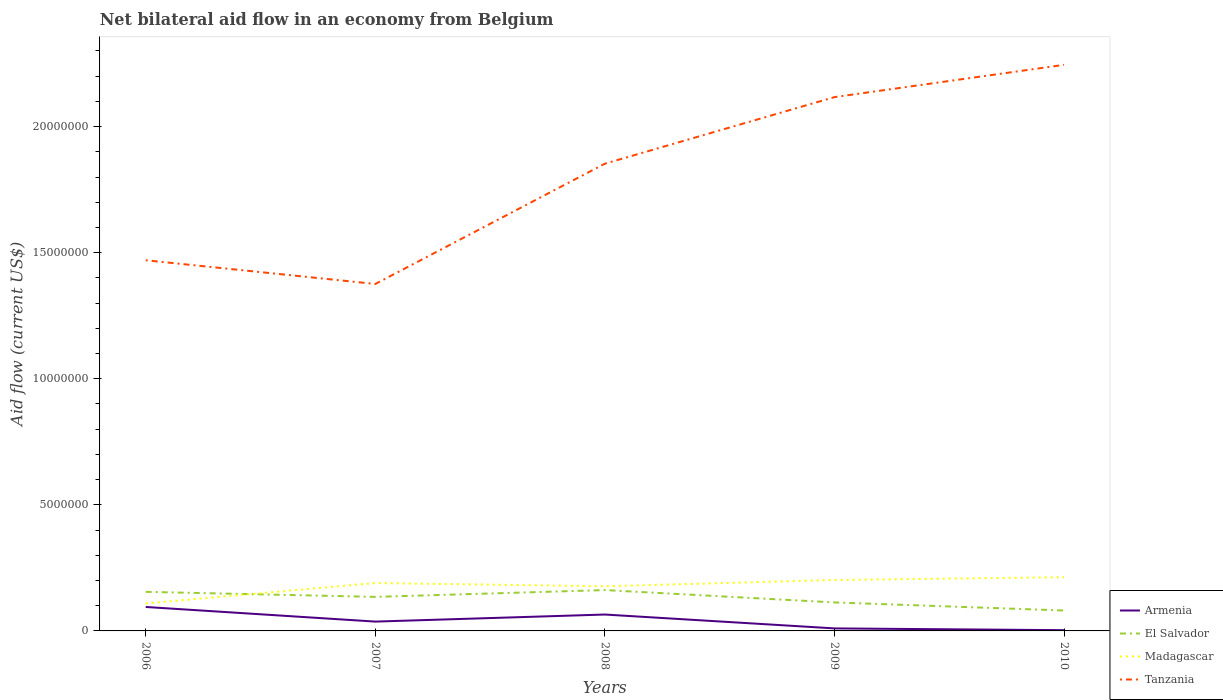Is the number of lines equal to the number of legend labels?
Your response must be concise. Yes. Across all years, what is the maximum net bilateral aid flow in Madagascar?
Provide a succinct answer. 1.09e+06. What is the total net bilateral aid flow in Armenia in the graph?
Your response must be concise. 7.00e+04. What is the difference between the highest and the second highest net bilateral aid flow in Armenia?
Provide a short and direct response. 9.20e+05. How many lines are there?
Provide a succinct answer. 4. How many years are there in the graph?
Your response must be concise. 5. What is the difference between two consecutive major ticks on the Y-axis?
Your answer should be compact. 5.00e+06. Are the values on the major ticks of Y-axis written in scientific E-notation?
Your answer should be very brief. No. Where does the legend appear in the graph?
Keep it short and to the point. Bottom right. How many legend labels are there?
Provide a short and direct response. 4. What is the title of the graph?
Give a very brief answer. Net bilateral aid flow in an economy from Belgium. What is the label or title of the X-axis?
Offer a very short reply. Years. What is the Aid flow (current US$) in Armenia in 2006?
Make the answer very short. 9.50e+05. What is the Aid flow (current US$) in El Salvador in 2006?
Offer a terse response. 1.55e+06. What is the Aid flow (current US$) of Madagascar in 2006?
Your answer should be very brief. 1.09e+06. What is the Aid flow (current US$) of Tanzania in 2006?
Your answer should be very brief. 1.47e+07. What is the Aid flow (current US$) of El Salvador in 2007?
Ensure brevity in your answer.  1.35e+06. What is the Aid flow (current US$) of Madagascar in 2007?
Provide a short and direct response. 1.90e+06. What is the Aid flow (current US$) in Tanzania in 2007?
Your answer should be compact. 1.38e+07. What is the Aid flow (current US$) in Armenia in 2008?
Your answer should be compact. 6.50e+05. What is the Aid flow (current US$) in El Salvador in 2008?
Your answer should be compact. 1.62e+06. What is the Aid flow (current US$) of Madagascar in 2008?
Make the answer very short. 1.77e+06. What is the Aid flow (current US$) of Tanzania in 2008?
Keep it short and to the point. 1.85e+07. What is the Aid flow (current US$) of El Salvador in 2009?
Your response must be concise. 1.13e+06. What is the Aid flow (current US$) in Madagascar in 2009?
Your response must be concise. 2.02e+06. What is the Aid flow (current US$) of Tanzania in 2009?
Give a very brief answer. 2.12e+07. What is the Aid flow (current US$) of El Salvador in 2010?
Your response must be concise. 8.10e+05. What is the Aid flow (current US$) in Madagascar in 2010?
Your answer should be very brief. 2.13e+06. What is the Aid flow (current US$) in Tanzania in 2010?
Provide a succinct answer. 2.24e+07. Across all years, what is the maximum Aid flow (current US$) of Armenia?
Provide a succinct answer. 9.50e+05. Across all years, what is the maximum Aid flow (current US$) of El Salvador?
Provide a short and direct response. 1.62e+06. Across all years, what is the maximum Aid flow (current US$) in Madagascar?
Offer a very short reply. 2.13e+06. Across all years, what is the maximum Aid flow (current US$) in Tanzania?
Ensure brevity in your answer.  2.24e+07. Across all years, what is the minimum Aid flow (current US$) in Armenia?
Make the answer very short. 3.00e+04. Across all years, what is the minimum Aid flow (current US$) of El Salvador?
Offer a very short reply. 8.10e+05. Across all years, what is the minimum Aid flow (current US$) in Madagascar?
Give a very brief answer. 1.09e+06. Across all years, what is the minimum Aid flow (current US$) in Tanzania?
Give a very brief answer. 1.38e+07. What is the total Aid flow (current US$) in Armenia in the graph?
Give a very brief answer. 2.10e+06. What is the total Aid flow (current US$) of El Salvador in the graph?
Your response must be concise. 6.46e+06. What is the total Aid flow (current US$) in Madagascar in the graph?
Your answer should be very brief. 8.91e+06. What is the total Aid flow (current US$) of Tanzania in the graph?
Make the answer very short. 9.06e+07. What is the difference between the Aid flow (current US$) of Armenia in 2006 and that in 2007?
Your answer should be very brief. 5.80e+05. What is the difference between the Aid flow (current US$) of El Salvador in 2006 and that in 2007?
Ensure brevity in your answer.  2.00e+05. What is the difference between the Aid flow (current US$) of Madagascar in 2006 and that in 2007?
Your answer should be very brief. -8.10e+05. What is the difference between the Aid flow (current US$) of Tanzania in 2006 and that in 2007?
Offer a terse response. 9.40e+05. What is the difference between the Aid flow (current US$) in El Salvador in 2006 and that in 2008?
Ensure brevity in your answer.  -7.00e+04. What is the difference between the Aid flow (current US$) of Madagascar in 2006 and that in 2008?
Your answer should be compact. -6.80e+05. What is the difference between the Aid flow (current US$) of Tanzania in 2006 and that in 2008?
Keep it short and to the point. -3.83e+06. What is the difference between the Aid flow (current US$) of Armenia in 2006 and that in 2009?
Your answer should be very brief. 8.50e+05. What is the difference between the Aid flow (current US$) of El Salvador in 2006 and that in 2009?
Offer a very short reply. 4.20e+05. What is the difference between the Aid flow (current US$) in Madagascar in 2006 and that in 2009?
Your response must be concise. -9.30e+05. What is the difference between the Aid flow (current US$) of Tanzania in 2006 and that in 2009?
Provide a succinct answer. -6.47e+06. What is the difference between the Aid flow (current US$) of Armenia in 2006 and that in 2010?
Ensure brevity in your answer.  9.20e+05. What is the difference between the Aid flow (current US$) of El Salvador in 2006 and that in 2010?
Make the answer very short. 7.40e+05. What is the difference between the Aid flow (current US$) in Madagascar in 2006 and that in 2010?
Give a very brief answer. -1.04e+06. What is the difference between the Aid flow (current US$) in Tanzania in 2006 and that in 2010?
Your answer should be compact. -7.75e+06. What is the difference between the Aid flow (current US$) of Armenia in 2007 and that in 2008?
Provide a short and direct response. -2.80e+05. What is the difference between the Aid flow (current US$) in El Salvador in 2007 and that in 2008?
Make the answer very short. -2.70e+05. What is the difference between the Aid flow (current US$) in Madagascar in 2007 and that in 2008?
Give a very brief answer. 1.30e+05. What is the difference between the Aid flow (current US$) of Tanzania in 2007 and that in 2008?
Ensure brevity in your answer.  -4.77e+06. What is the difference between the Aid flow (current US$) of Armenia in 2007 and that in 2009?
Provide a short and direct response. 2.70e+05. What is the difference between the Aid flow (current US$) of El Salvador in 2007 and that in 2009?
Make the answer very short. 2.20e+05. What is the difference between the Aid flow (current US$) of Tanzania in 2007 and that in 2009?
Provide a succinct answer. -7.41e+06. What is the difference between the Aid flow (current US$) of El Salvador in 2007 and that in 2010?
Keep it short and to the point. 5.40e+05. What is the difference between the Aid flow (current US$) of Tanzania in 2007 and that in 2010?
Give a very brief answer. -8.69e+06. What is the difference between the Aid flow (current US$) in El Salvador in 2008 and that in 2009?
Your answer should be very brief. 4.90e+05. What is the difference between the Aid flow (current US$) in Madagascar in 2008 and that in 2009?
Your response must be concise. -2.50e+05. What is the difference between the Aid flow (current US$) in Tanzania in 2008 and that in 2009?
Ensure brevity in your answer.  -2.64e+06. What is the difference between the Aid flow (current US$) in Armenia in 2008 and that in 2010?
Give a very brief answer. 6.20e+05. What is the difference between the Aid flow (current US$) of El Salvador in 2008 and that in 2010?
Offer a terse response. 8.10e+05. What is the difference between the Aid flow (current US$) of Madagascar in 2008 and that in 2010?
Keep it short and to the point. -3.60e+05. What is the difference between the Aid flow (current US$) in Tanzania in 2008 and that in 2010?
Your answer should be compact. -3.92e+06. What is the difference between the Aid flow (current US$) of Armenia in 2009 and that in 2010?
Give a very brief answer. 7.00e+04. What is the difference between the Aid flow (current US$) of Madagascar in 2009 and that in 2010?
Provide a short and direct response. -1.10e+05. What is the difference between the Aid flow (current US$) in Tanzania in 2009 and that in 2010?
Make the answer very short. -1.28e+06. What is the difference between the Aid flow (current US$) in Armenia in 2006 and the Aid flow (current US$) in El Salvador in 2007?
Make the answer very short. -4.00e+05. What is the difference between the Aid flow (current US$) of Armenia in 2006 and the Aid flow (current US$) of Madagascar in 2007?
Provide a short and direct response. -9.50e+05. What is the difference between the Aid flow (current US$) in Armenia in 2006 and the Aid flow (current US$) in Tanzania in 2007?
Keep it short and to the point. -1.28e+07. What is the difference between the Aid flow (current US$) of El Salvador in 2006 and the Aid flow (current US$) of Madagascar in 2007?
Give a very brief answer. -3.50e+05. What is the difference between the Aid flow (current US$) in El Salvador in 2006 and the Aid flow (current US$) in Tanzania in 2007?
Make the answer very short. -1.22e+07. What is the difference between the Aid flow (current US$) in Madagascar in 2006 and the Aid flow (current US$) in Tanzania in 2007?
Provide a short and direct response. -1.27e+07. What is the difference between the Aid flow (current US$) of Armenia in 2006 and the Aid flow (current US$) of El Salvador in 2008?
Your answer should be compact. -6.70e+05. What is the difference between the Aid flow (current US$) in Armenia in 2006 and the Aid flow (current US$) in Madagascar in 2008?
Give a very brief answer. -8.20e+05. What is the difference between the Aid flow (current US$) of Armenia in 2006 and the Aid flow (current US$) of Tanzania in 2008?
Provide a short and direct response. -1.76e+07. What is the difference between the Aid flow (current US$) of El Salvador in 2006 and the Aid flow (current US$) of Tanzania in 2008?
Offer a very short reply. -1.70e+07. What is the difference between the Aid flow (current US$) of Madagascar in 2006 and the Aid flow (current US$) of Tanzania in 2008?
Offer a very short reply. -1.74e+07. What is the difference between the Aid flow (current US$) in Armenia in 2006 and the Aid flow (current US$) in El Salvador in 2009?
Give a very brief answer. -1.80e+05. What is the difference between the Aid flow (current US$) of Armenia in 2006 and the Aid flow (current US$) of Madagascar in 2009?
Ensure brevity in your answer.  -1.07e+06. What is the difference between the Aid flow (current US$) of Armenia in 2006 and the Aid flow (current US$) of Tanzania in 2009?
Keep it short and to the point. -2.02e+07. What is the difference between the Aid flow (current US$) of El Salvador in 2006 and the Aid flow (current US$) of Madagascar in 2009?
Your answer should be compact. -4.70e+05. What is the difference between the Aid flow (current US$) in El Salvador in 2006 and the Aid flow (current US$) in Tanzania in 2009?
Your response must be concise. -1.96e+07. What is the difference between the Aid flow (current US$) of Madagascar in 2006 and the Aid flow (current US$) of Tanzania in 2009?
Make the answer very short. -2.01e+07. What is the difference between the Aid flow (current US$) in Armenia in 2006 and the Aid flow (current US$) in Madagascar in 2010?
Make the answer very short. -1.18e+06. What is the difference between the Aid flow (current US$) of Armenia in 2006 and the Aid flow (current US$) of Tanzania in 2010?
Offer a terse response. -2.15e+07. What is the difference between the Aid flow (current US$) in El Salvador in 2006 and the Aid flow (current US$) in Madagascar in 2010?
Ensure brevity in your answer.  -5.80e+05. What is the difference between the Aid flow (current US$) in El Salvador in 2006 and the Aid flow (current US$) in Tanzania in 2010?
Make the answer very short. -2.09e+07. What is the difference between the Aid flow (current US$) of Madagascar in 2006 and the Aid flow (current US$) of Tanzania in 2010?
Offer a terse response. -2.14e+07. What is the difference between the Aid flow (current US$) of Armenia in 2007 and the Aid flow (current US$) of El Salvador in 2008?
Offer a terse response. -1.25e+06. What is the difference between the Aid flow (current US$) in Armenia in 2007 and the Aid flow (current US$) in Madagascar in 2008?
Provide a succinct answer. -1.40e+06. What is the difference between the Aid flow (current US$) of Armenia in 2007 and the Aid flow (current US$) of Tanzania in 2008?
Provide a short and direct response. -1.82e+07. What is the difference between the Aid flow (current US$) of El Salvador in 2007 and the Aid flow (current US$) of Madagascar in 2008?
Your answer should be very brief. -4.20e+05. What is the difference between the Aid flow (current US$) of El Salvador in 2007 and the Aid flow (current US$) of Tanzania in 2008?
Provide a succinct answer. -1.72e+07. What is the difference between the Aid flow (current US$) of Madagascar in 2007 and the Aid flow (current US$) of Tanzania in 2008?
Your answer should be very brief. -1.66e+07. What is the difference between the Aid flow (current US$) in Armenia in 2007 and the Aid flow (current US$) in El Salvador in 2009?
Provide a succinct answer. -7.60e+05. What is the difference between the Aid flow (current US$) of Armenia in 2007 and the Aid flow (current US$) of Madagascar in 2009?
Keep it short and to the point. -1.65e+06. What is the difference between the Aid flow (current US$) in Armenia in 2007 and the Aid flow (current US$) in Tanzania in 2009?
Offer a very short reply. -2.08e+07. What is the difference between the Aid flow (current US$) of El Salvador in 2007 and the Aid flow (current US$) of Madagascar in 2009?
Your answer should be compact. -6.70e+05. What is the difference between the Aid flow (current US$) in El Salvador in 2007 and the Aid flow (current US$) in Tanzania in 2009?
Your response must be concise. -1.98e+07. What is the difference between the Aid flow (current US$) in Madagascar in 2007 and the Aid flow (current US$) in Tanzania in 2009?
Offer a terse response. -1.93e+07. What is the difference between the Aid flow (current US$) of Armenia in 2007 and the Aid flow (current US$) of El Salvador in 2010?
Provide a succinct answer. -4.40e+05. What is the difference between the Aid flow (current US$) in Armenia in 2007 and the Aid flow (current US$) in Madagascar in 2010?
Your response must be concise. -1.76e+06. What is the difference between the Aid flow (current US$) in Armenia in 2007 and the Aid flow (current US$) in Tanzania in 2010?
Ensure brevity in your answer.  -2.21e+07. What is the difference between the Aid flow (current US$) in El Salvador in 2007 and the Aid flow (current US$) in Madagascar in 2010?
Your answer should be compact. -7.80e+05. What is the difference between the Aid flow (current US$) of El Salvador in 2007 and the Aid flow (current US$) of Tanzania in 2010?
Offer a terse response. -2.11e+07. What is the difference between the Aid flow (current US$) of Madagascar in 2007 and the Aid flow (current US$) of Tanzania in 2010?
Your answer should be very brief. -2.06e+07. What is the difference between the Aid flow (current US$) of Armenia in 2008 and the Aid flow (current US$) of El Salvador in 2009?
Make the answer very short. -4.80e+05. What is the difference between the Aid flow (current US$) in Armenia in 2008 and the Aid flow (current US$) in Madagascar in 2009?
Make the answer very short. -1.37e+06. What is the difference between the Aid flow (current US$) of Armenia in 2008 and the Aid flow (current US$) of Tanzania in 2009?
Your answer should be compact. -2.05e+07. What is the difference between the Aid flow (current US$) of El Salvador in 2008 and the Aid flow (current US$) of Madagascar in 2009?
Your answer should be very brief. -4.00e+05. What is the difference between the Aid flow (current US$) in El Salvador in 2008 and the Aid flow (current US$) in Tanzania in 2009?
Provide a succinct answer. -1.96e+07. What is the difference between the Aid flow (current US$) in Madagascar in 2008 and the Aid flow (current US$) in Tanzania in 2009?
Offer a very short reply. -1.94e+07. What is the difference between the Aid flow (current US$) of Armenia in 2008 and the Aid flow (current US$) of El Salvador in 2010?
Offer a terse response. -1.60e+05. What is the difference between the Aid flow (current US$) in Armenia in 2008 and the Aid flow (current US$) in Madagascar in 2010?
Provide a short and direct response. -1.48e+06. What is the difference between the Aid flow (current US$) of Armenia in 2008 and the Aid flow (current US$) of Tanzania in 2010?
Provide a short and direct response. -2.18e+07. What is the difference between the Aid flow (current US$) of El Salvador in 2008 and the Aid flow (current US$) of Madagascar in 2010?
Your response must be concise. -5.10e+05. What is the difference between the Aid flow (current US$) of El Salvador in 2008 and the Aid flow (current US$) of Tanzania in 2010?
Make the answer very short. -2.08e+07. What is the difference between the Aid flow (current US$) in Madagascar in 2008 and the Aid flow (current US$) in Tanzania in 2010?
Your response must be concise. -2.07e+07. What is the difference between the Aid flow (current US$) in Armenia in 2009 and the Aid flow (current US$) in El Salvador in 2010?
Your response must be concise. -7.10e+05. What is the difference between the Aid flow (current US$) of Armenia in 2009 and the Aid flow (current US$) of Madagascar in 2010?
Keep it short and to the point. -2.03e+06. What is the difference between the Aid flow (current US$) of Armenia in 2009 and the Aid flow (current US$) of Tanzania in 2010?
Your response must be concise. -2.24e+07. What is the difference between the Aid flow (current US$) of El Salvador in 2009 and the Aid flow (current US$) of Tanzania in 2010?
Offer a very short reply. -2.13e+07. What is the difference between the Aid flow (current US$) in Madagascar in 2009 and the Aid flow (current US$) in Tanzania in 2010?
Offer a terse response. -2.04e+07. What is the average Aid flow (current US$) of El Salvador per year?
Offer a terse response. 1.29e+06. What is the average Aid flow (current US$) in Madagascar per year?
Your answer should be compact. 1.78e+06. What is the average Aid flow (current US$) in Tanzania per year?
Provide a succinct answer. 1.81e+07. In the year 2006, what is the difference between the Aid flow (current US$) in Armenia and Aid flow (current US$) in El Salvador?
Provide a succinct answer. -6.00e+05. In the year 2006, what is the difference between the Aid flow (current US$) of Armenia and Aid flow (current US$) of Madagascar?
Ensure brevity in your answer.  -1.40e+05. In the year 2006, what is the difference between the Aid flow (current US$) of Armenia and Aid flow (current US$) of Tanzania?
Provide a succinct answer. -1.38e+07. In the year 2006, what is the difference between the Aid flow (current US$) of El Salvador and Aid flow (current US$) of Madagascar?
Keep it short and to the point. 4.60e+05. In the year 2006, what is the difference between the Aid flow (current US$) of El Salvador and Aid flow (current US$) of Tanzania?
Offer a terse response. -1.32e+07. In the year 2006, what is the difference between the Aid flow (current US$) of Madagascar and Aid flow (current US$) of Tanzania?
Offer a terse response. -1.36e+07. In the year 2007, what is the difference between the Aid flow (current US$) in Armenia and Aid flow (current US$) in El Salvador?
Provide a succinct answer. -9.80e+05. In the year 2007, what is the difference between the Aid flow (current US$) of Armenia and Aid flow (current US$) of Madagascar?
Offer a very short reply. -1.53e+06. In the year 2007, what is the difference between the Aid flow (current US$) in Armenia and Aid flow (current US$) in Tanzania?
Keep it short and to the point. -1.34e+07. In the year 2007, what is the difference between the Aid flow (current US$) of El Salvador and Aid flow (current US$) of Madagascar?
Ensure brevity in your answer.  -5.50e+05. In the year 2007, what is the difference between the Aid flow (current US$) of El Salvador and Aid flow (current US$) of Tanzania?
Offer a terse response. -1.24e+07. In the year 2007, what is the difference between the Aid flow (current US$) in Madagascar and Aid flow (current US$) in Tanzania?
Keep it short and to the point. -1.19e+07. In the year 2008, what is the difference between the Aid flow (current US$) in Armenia and Aid flow (current US$) in El Salvador?
Keep it short and to the point. -9.70e+05. In the year 2008, what is the difference between the Aid flow (current US$) in Armenia and Aid flow (current US$) in Madagascar?
Give a very brief answer. -1.12e+06. In the year 2008, what is the difference between the Aid flow (current US$) of Armenia and Aid flow (current US$) of Tanzania?
Your answer should be compact. -1.79e+07. In the year 2008, what is the difference between the Aid flow (current US$) of El Salvador and Aid flow (current US$) of Tanzania?
Provide a succinct answer. -1.69e+07. In the year 2008, what is the difference between the Aid flow (current US$) of Madagascar and Aid flow (current US$) of Tanzania?
Offer a very short reply. -1.68e+07. In the year 2009, what is the difference between the Aid flow (current US$) in Armenia and Aid flow (current US$) in El Salvador?
Your response must be concise. -1.03e+06. In the year 2009, what is the difference between the Aid flow (current US$) of Armenia and Aid flow (current US$) of Madagascar?
Keep it short and to the point. -1.92e+06. In the year 2009, what is the difference between the Aid flow (current US$) in Armenia and Aid flow (current US$) in Tanzania?
Your answer should be very brief. -2.11e+07. In the year 2009, what is the difference between the Aid flow (current US$) of El Salvador and Aid flow (current US$) of Madagascar?
Keep it short and to the point. -8.90e+05. In the year 2009, what is the difference between the Aid flow (current US$) in El Salvador and Aid flow (current US$) in Tanzania?
Ensure brevity in your answer.  -2.00e+07. In the year 2009, what is the difference between the Aid flow (current US$) in Madagascar and Aid flow (current US$) in Tanzania?
Provide a succinct answer. -1.92e+07. In the year 2010, what is the difference between the Aid flow (current US$) in Armenia and Aid flow (current US$) in El Salvador?
Keep it short and to the point. -7.80e+05. In the year 2010, what is the difference between the Aid flow (current US$) in Armenia and Aid flow (current US$) in Madagascar?
Your response must be concise. -2.10e+06. In the year 2010, what is the difference between the Aid flow (current US$) of Armenia and Aid flow (current US$) of Tanzania?
Ensure brevity in your answer.  -2.24e+07. In the year 2010, what is the difference between the Aid flow (current US$) in El Salvador and Aid flow (current US$) in Madagascar?
Offer a very short reply. -1.32e+06. In the year 2010, what is the difference between the Aid flow (current US$) of El Salvador and Aid flow (current US$) of Tanzania?
Ensure brevity in your answer.  -2.16e+07. In the year 2010, what is the difference between the Aid flow (current US$) in Madagascar and Aid flow (current US$) in Tanzania?
Make the answer very short. -2.03e+07. What is the ratio of the Aid flow (current US$) of Armenia in 2006 to that in 2007?
Give a very brief answer. 2.57. What is the ratio of the Aid flow (current US$) of El Salvador in 2006 to that in 2007?
Ensure brevity in your answer.  1.15. What is the ratio of the Aid flow (current US$) in Madagascar in 2006 to that in 2007?
Make the answer very short. 0.57. What is the ratio of the Aid flow (current US$) in Tanzania in 2006 to that in 2007?
Your answer should be compact. 1.07. What is the ratio of the Aid flow (current US$) in Armenia in 2006 to that in 2008?
Provide a succinct answer. 1.46. What is the ratio of the Aid flow (current US$) of El Salvador in 2006 to that in 2008?
Make the answer very short. 0.96. What is the ratio of the Aid flow (current US$) in Madagascar in 2006 to that in 2008?
Give a very brief answer. 0.62. What is the ratio of the Aid flow (current US$) in Tanzania in 2006 to that in 2008?
Your response must be concise. 0.79. What is the ratio of the Aid flow (current US$) in El Salvador in 2006 to that in 2009?
Your answer should be very brief. 1.37. What is the ratio of the Aid flow (current US$) in Madagascar in 2006 to that in 2009?
Give a very brief answer. 0.54. What is the ratio of the Aid flow (current US$) in Tanzania in 2006 to that in 2009?
Your answer should be very brief. 0.69. What is the ratio of the Aid flow (current US$) of Armenia in 2006 to that in 2010?
Your answer should be compact. 31.67. What is the ratio of the Aid flow (current US$) in El Salvador in 2006 to that in 2010?
Provide a short and direct response. 1.91. What is the ratio of the Aid flow (current US$) of Madagascar in 2006 to that in 2010?
Make the answer very short. 0.51. What is the ratio of the Aid flow (current US$) of Tanzania in 2006 to that in 2010?
Ensure brevity in your answer.  0.65. What is the ratio of the Aid flow (current US$) of Armenia in 2007 to that in 2008?
Offer a very short reply. 0.57. What is the ratio of the Aid flow (current US$) in El Salvador in 2007 to that in 2008?
Make the answer very short. 0.83. What is the ratio of the Aid flow (current US$) in Madagascar in 2007 to that in 2008?
Offer a terse response. 1.07. What is the ratio of the Aid flow (current US$) of Tanzania in 2007 to that in 2008?
Ensure brevity in your answer.  0.74. What is the ratio of the Aid flow (current US$) of Armenia in 2007 to that in 2009?
Your answer should be compact. 3.7. What is the ratio of the Aid flow (current US$) in El Salvador in 2007 to that in 2009?
Your response must be concise. 1.19. What is the ratio of the Aid flow (current US$) in Madagascar in 2007 to that in 2009?
Your answer should be very brief. 0.94. What is the ratio of the Aid flow (current US$) in Tanzania in 2007 to that in 2009?
Your answer should be compact. 0.65. What is the ratio of the Aid flow (current US$) of Armenia in 2007 to that in 2010?
Provide a short and direct response. 12.33. What is the ratio of the Aid flow (current US$) in El Salvador in 2007 to that in 2010?
Make the answer very short. 1.67. What is the ratio of the Aid flow (current US$) in Madagascar in 2007 to that in 2010?
Offer a very short reply. 0.89. What is the ratio of the Aid flow (current US$) in Tanzania in 2007 to that in 2010?
Your response must be concise. 0.61. What is the ratio of the Aid flow (current US$) in El Salvador in 2008 to that in 2009?
Your answer should be compact. 1.43. What is the ratio of the Aid flow (current US$) in Madagascar in 2008 to that in 2009?
Offer a terse response. 0.88. What is the ratio of the Aid flow (current US$) in Tanzania in 2008 to that in 2009?
Provide a short and direct response. 0.88. What is the ratio of the Aid flow (current US$) in Armenia in 2008 to that in 2010?
Make the answer very short. 21.67. What is the ratio of the Aid flow (current US$) in El Salvador in 2008 to that in 2010?
Your answer should be very brief. 2. What is the ratio of the Aid flow (current US$) in Madagascar in 2008 to that in 2010?
Provide a succinct answer. 0.83. What is the ratio of the Aid flow (current US$) in Tanzania in 2008 to that in 2010?
Ensure brevity in your answer.  0.83. What is the ratio of the Aid flow (current US$) of Armenia in 2009 to that in 2010?
Your answer should be very brief. 3.33. What is the ratio of the Aid flow (current US$) in El Salvador in 2009 to that in 2010?
Keep it short and to the point. 1.4. What is the ratio of the Aid flow (current US$) in Madagascar in 2009 to that in 2010?
Ensure brevity in your answer.  0.95. What is the ratio of the Aid flow (current US$) of Tanzania in 2009 to that in 2010?
Ensure brevity in your answer.  0.94. What is the difference between the highest and the second highest Aid flow (current US$) in El Salvador?
Your answer should be compact. 7.00e+04. What is the difference between the highest and the second highest Aid flow (current US$) in Madagascar?
Provide a succinct answer. 1.10e+05. What is the difference between the highest and the second highest Aid flow (current US$) in Tanzania?
Provide a succinct answer. 1.28e+06. What is the difference between the highest and the lowest Aid flow (current US$) of Armenia?
Your answer should be very brief. 9.20e+05. What is the difference between the highest and the lowest Aid flow (current US$) of El Salvador?
Keep it short and to the point. 8.10e+05. What is the difference between the highest and the lowest Aid flow (current US$) of Madagascar?
Provide a succinct answer. 1.04e+06. What is the difference between the highest and the lowest Aid flow (current US$) in Tanzania?
Make the answer very short. 8.69e+06. 